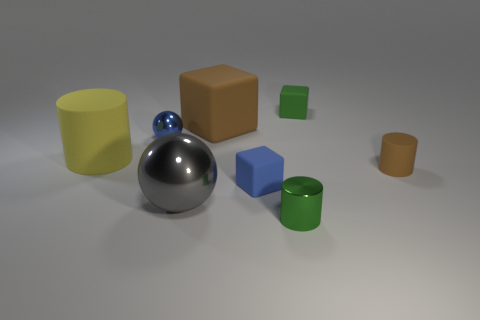Is there any other thing that has the same size as the brown rubber cylinder?
Provide a succinct answer. Yes. Is there a matte object that has the same color as the small shiny cylinder?
Keep it short and to the point. Yes. Does the small blue block have the same material as the big yellow object?
Provide a succinct answer. Yes. What number of other big objects have the same shape as the large gray metal object?
Offer a terse response. 0. There is a large object that is made of the same material as the tiny green cylinder; what shape is it?
Ensure brevity in your answer.  Sphere. There is a metal thing behind the rubber cylinder that is on the right side of the brown rubber block; what color is it?
Ensure brevity in your answer.  Blue. Do the big ball and the metal cylinder have the same color?
Your answer should be very brief. No. What material is the large brown thing that is behind the tiny metallic object that is behind the large rubber cylinder?
Keep it short and to the point. Rubber. There is a blue object that is the same shape as the gray metal thing; what material is it?
Your answer should be compact. Metal. Is there a tiny green object in front of the brown rubber thing that is left of the tiny thing behind the big matte cube?
Give a very brief answer. Yes. 